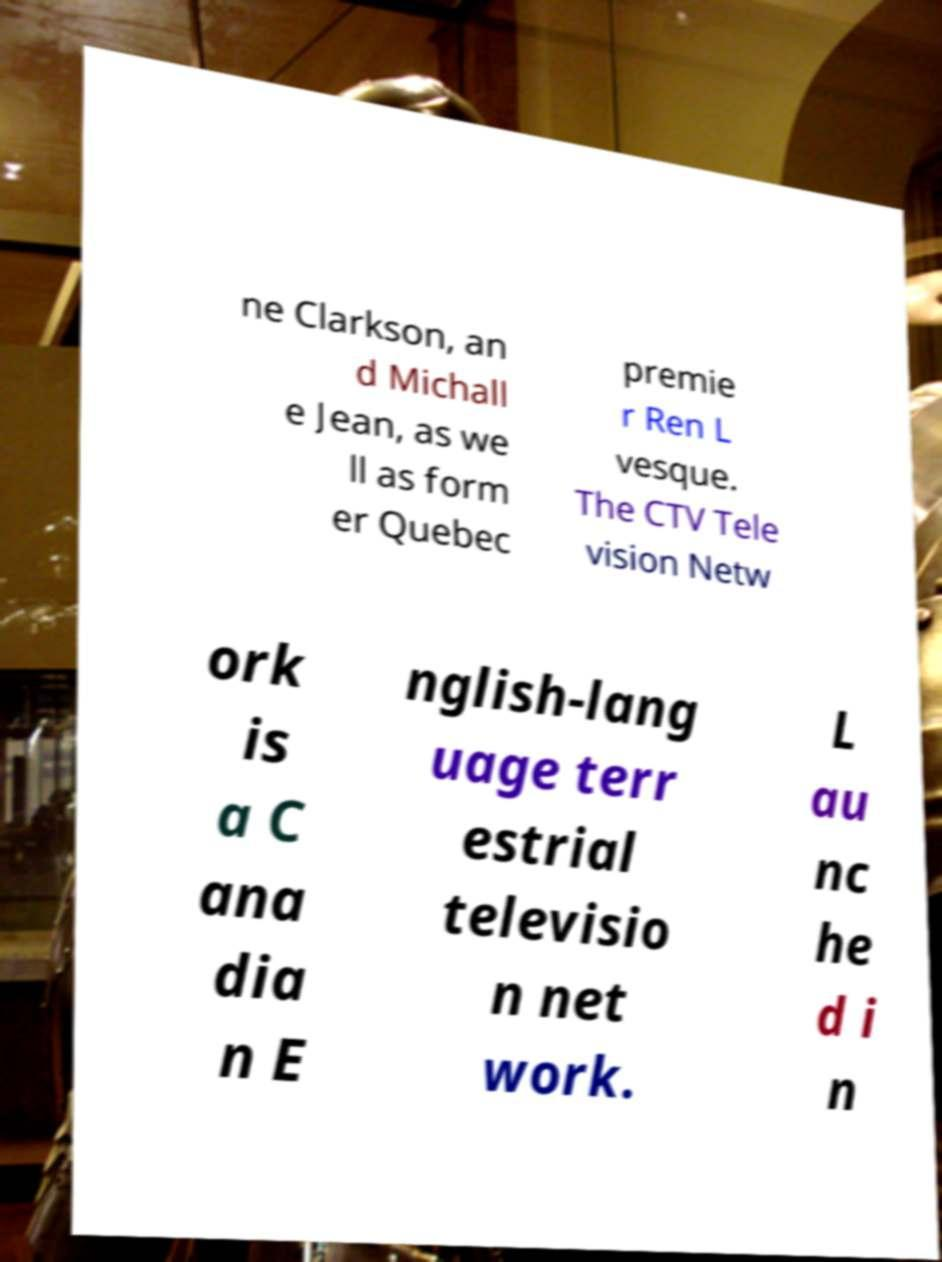Can you read and provide the text displayed in the image?This photo seems to have some interesting text. Can you extract and type it out for me? ne Clarkson, an d Michall e Jean, as we ll as form er Quebec premie r Ren L vesque. The CTV Tele vision Netw ork is a C ana dia n E nglish-lang uage terr estrial televisio n net work. L au nc he d i n 